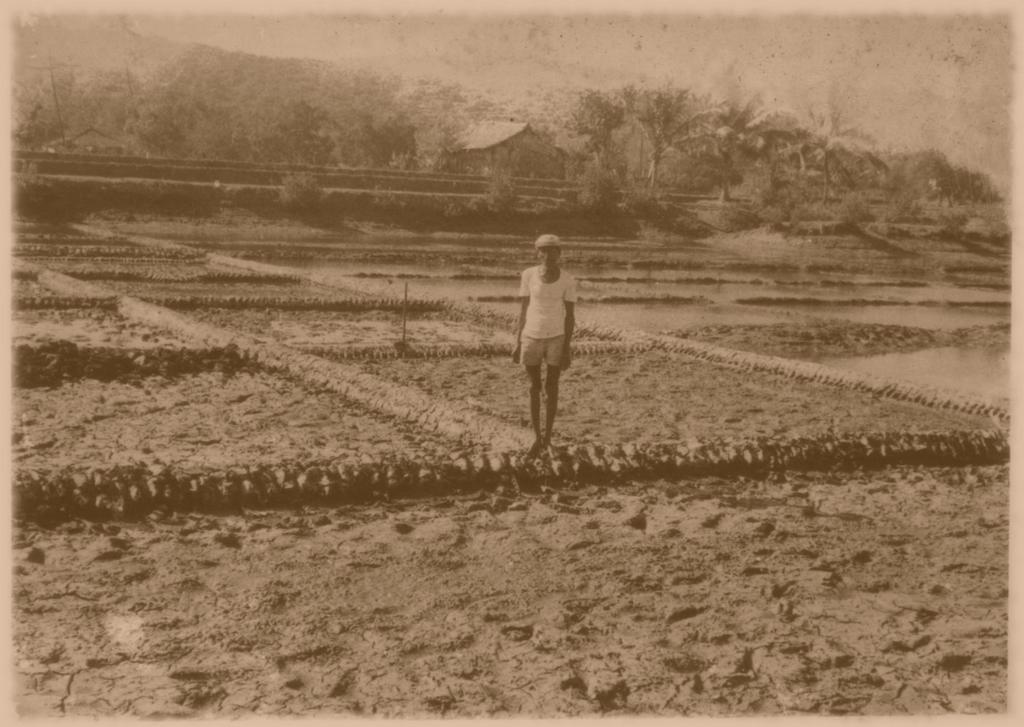Who is the main subject in the foreground of the image? There is a man in the foreground of the image. What is the man doing in the image? The man is in farming fields. What can be seen in the background of the image? There is a house, trees, mountains, and the sky visible in the background of the image. How many planes can be seen flying over the mountains in the image? There are no planes visible in the image; it only shows a man in farming fields, a house, trees, mountains, and the sky. 